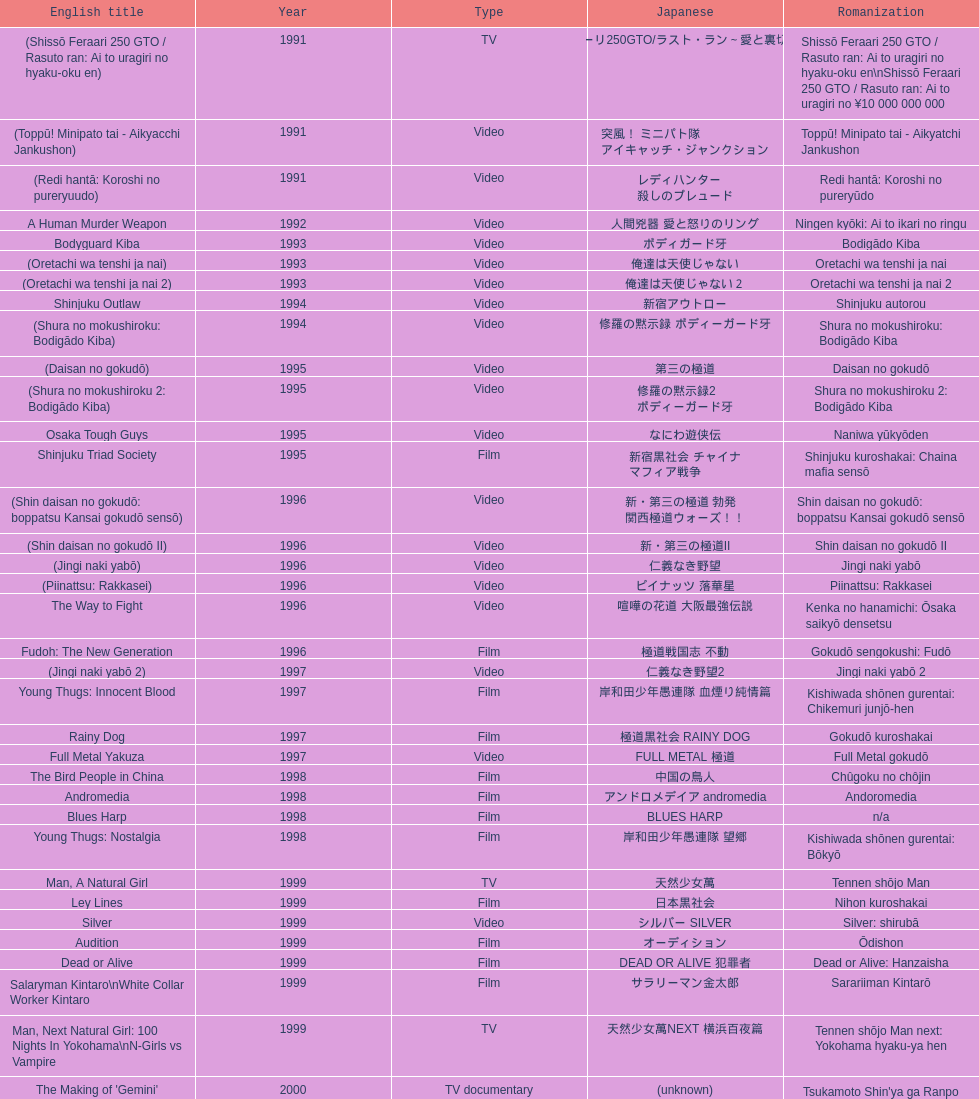Were more air on tv or video? Video. Could you parse the entire table? {'header': ['English title', 'Year', 'Type', 'Japanese', 'Romanization'], 'rows': [['(Shissō Feraari 250 GTO / Rasuto ran: Ai to uragiri no hyaku-oku en)', '1991', 'TV', '疾走フェラーリ250GTO/ラスト・ラン～愛と裏切りの百億円', 'Shissō Feraari 250 GTO / Rasuto ran: Ai to uragiri no hyaku-oku en\\nShissō Feraari 250 GTO / Rasuto ran: Ai to uragiri no ¥10 000 000 000'], ['(Toppū! Minipato tai - Aikyacchi Jankushon)', '1991', 'Video', '突風！ ミニパト隊 アイキャッチ・ジャンクション', 'Toppū! Minipato tai - Aikyatchi Jankushon'], ['(Redi hantā: Koroshi no pureryuudo)', '1991', 'Video', 'レディハンター 殺しのプレュード', 'Redi hantā: Koroshi no pureryūdo'], ['A Human Murder Weapon', '1992', 'Video', '人間兇器 愛と怒りのリング', 'Ningen kyōki: Ai to ikari no ringu'], ['Bodyguard Kiba', '1993', 'Video', 'ボディガード牙', 'Bodigādo Kiba'], ['(Oretachi wa tenshi ja nai)', '1993', 'Video', '俺達は天使じゃない', 'Oretachi wa tenshi ja nai'], ['(Oretachi wa tenshi ja nai 2)', '1993', 'Video', '俺達は天使じゃない２', 'Oretachi wa tenshi ja nai 2'], ['Shinjuku Outlaw', '1994', 'Video', '新宿アウトロー', 'Shinjuku autorou'], ['(Shura no mokushiroku: Bodigādo Kiba)', '1994', 'Video', '修羅の黙示録 ボディーガード牙', 'Shura no mokushiroku: Bodigādo Kiba'], ['(Daisan no gokudō)', '1995', 'Video', '第三の極道', 'Daisan no gokudō'], ['(Shura no mokushiroku 2: Bodigādo Kiba)', '1995', 'Video', '修羅の黙示録2 ボディーガード牙', 'Shura no mokushiroku 2: Bodigādo Kiba'], ['Osaka Tough Guys', '1995', 'Video', 'なにわ遊侠伝', 'Naniwa yūkyōden'], ['Shinjuku Triad Society', '1995', 'Film', '新宿黒社会 チャイナ マフィア戦争', 'Shinjuku kuroshakai: Chaina mafia sensō'], ['(Shin daisan no gokudō: boppatsu Kansai gokudō sensō)', '1996', 'Video', '新・第三の極道 勃発 関西極道ウォーズ！！', 'Shin daisan no gokudō: boppatsu Kansai gokudō sensō'], ['(Shin daisan no gokudō II)', '1996', 'Video', '新・第三の極道II', 'Shin daisan no gokudō II'], ['(Jingi naki yabō)', '1996', 'Video', '仁義なき野望', 'Jingi naki yabō'], ['(Piinattsu: Rakkasei)', '1996', 'Video', 'ピイナッツ 落華星', 'Piinattsu: Rakkasei'], ['The Way to Fight', '1996', 'Video', '喧嘩の花道 大阪最強伝説', 'Kenka no hanamichi: Ōsaka saikyō densetsu'], ['Fudoh: The New Generation', '1996', 'Film', '極道戦国志 不動', 'Gokudō sengokushi: Fudō'], ['(Jingi naki yabō 2)', '1997', 'Video', '仁義なき野望2', 'Jingi naki yabō 2'], ['Young Thugs: Innocent Blood', '1997', 'Film', '岸和田少年愚連隊 血煙り純情篇', 'Kishiwada shōnen gurentai: Chikemuri junjō-hen'], ['Rainy Dog', '1997', 'Film', '極道黒社会 RAINY DOG', 'Gokudō kuroshakai'], ['Full Metal Yakuza', '1997', 'Video', 'FULL METAL 極道', 'Full Metal gokudō'], ['The Bird People in China', '1998', 'Film', '中国の鳥人', 'Chûgoku no chôjin'], ['Andromedia', '1998', 'Film', 'アンドロメデイア andromedia', 'Andoromedia'], ['Blues Harp', '1998', 'Film', 'BLUES HARP', 'n/a'], ['Young Thugs: Nostalgia', '1998', 'Film', '岸和田少年愚連隊 望郷', 'Kishiwada shōnen gurentai: Bōkyō'], ['Man, A Natural Girl', '1999', 'TV', '天然少女萬', 'Tennen shōjo Man'], ['Ley Lines', '1999', 'Film', '日本黒社会', 'Nihon kuroshakai'], ['Silver', '1999', 'Video', 'シルバー SILVER', 'Silver: shirubā'], ['Audition', '1999', 'Film', 'オーディション', 'Ōdishon'], ['Dead or Alive', '1999', 'Film', 'DEAD OR ALIVE 犯罪者', 'Dead or Alive: Hanzaisha'], ['Salaryman Kintaro\\nWhite Collar Worker Kintaro', '1999', 'Film', 'サラリーマン金太郎', 'Sarariiman Kintarō'], ['Man, Next Natural Girl: 100 Nights In Yokohama\\nN-Girls vs Vampire', '1999', 'TV', '天然少女萬NEXT 横浜百夜篇', 'Tennen shōjo Man next: Yokohama hyaku-ya hen'], ["The Making of 'Gemini'", '2000', 'TV documentary', '(unknown)', "Tsukamoto Shin'ya ga Ranpo suru"], ['MPD Psycho', '2000', 'TV miniseries', '多重人格探偵サイコ', 'Tajū jinkaku tantei saiko: Amamiya Kazuhiko no kikan'], ['The City of Lost Souls\\nThe City of Strangers\\nThe Hazard City', '2000', 'Film', '漂流街 THE HAZARD CITY', 'Hyōryū-gai'], ['The Guys from Paradise', '2000', 'Film', '天国から来た男たち', 'Tengoku kara kita otoko-tachi'], ['Dead or Alive 2: Birds\\nDead or Alive 2: Runaway', '2000', 'Film', 'DEAD OR ALIVE 2 逃亡者', 'Dead or Alive 2: Tōbōsha'], ['(Kikuchi-jō monogatari: sakimori-tachi no uta)', '2001', 'Film', '鞠智城物語 防人たちの唄', 'Kikuchi-jō monogatari: sakimori-tachi no uta'], ['(Zuiketsu gensō: Tonkararin yume densetsu)', '2001', 'Film', '隧穴幻想 トンカラリン夢伝説', 'Zuiketsu gensō: Tonkararin yume densetsu'], ['Family', '2001', 'Film', 'FAMILY', 'n/a'], ['Visitor Q', '2001', 'Video', 'ビジターQ', 'Bijitā Q'], ['Ichi the Killer', '2001', 'Film', '殺し屋1', 'Koroshiya 1'], ['Agitator', '2001', 'Film', '荒ぶる魂たち', 'Araburu tamashii-tachi'], ['The Happiness of the Katakuris', '2001', 'Film', 'カタクリ家の幸福', 'Katakuri-ke no kōfuku'], ['Dead or Alive: Final', '2002', 'Film', 'DEAD OR ALIVE FINAL', 'n/a'], ['(Onna kunishū ikki)', '2002', '(unknown)', 'おんな 国衆一揆', 'Onna kunishū ikki'], ['Sabu', '2002', 'TV', 'SABU さぶ', 'Sabu'], ['Graveyard of Honor', '2002', 'Film', '新・仁義の墓場', 'Shin jingi no hakaba'], ['Shangri-La', '2002', 'Film', '金融破滅ニッポン 桃源郷の人々', "Kin'yū hametsu Nippon: Tōgenkyō no hito-bito"], ['Pandōra', '2002', 'Music video', 'パンドーラ', 'Pandōra'], ['Deadly Outlaw: Rekka\\nViolent Fire', '2002', 'Film', '実録・安藤昇侠道（アウトロー）伝 烈火', 'Jitsuroku Andō Noboru kyōdō-den: Rekka'], ['Pāto-taimu tantei', '2002', 'TV series', 'パートタイム探偵', 'Pāto-taimu tantei'], ['The Man in White', '2003', 'Film', '許されざる者', 'Yurusarezaru mono'], ['Gozu', '2003', 'Film', '極道恐怖大劇場 牛頭 GOZU', 'Gokudō kyōfu dai-gekijō: Gozu'], ['Yakuza Demon', '2003', 'Video', '鬼哭 kikoku', 'Kikoku'], ['Kōshōnin', '2003', 'TV', '交渉人', 'Kōshōnin'], ["One Missed Call\\nYou've Got a Call", '2003', 'Film', '着信アリ', 'Chakushin Ari'], ['Zebraman', '2004', 'Film', 'ゼブラーマン', 'Zeburāman'], ['Pāto-taimu tantei 2', '2004', 'TV', 'パートタイム探偵2', 'Pāto-taimu tantei 2'], ['Box segment in Three... Extremes', '2004', 'Segment in feature film', 'BOX（『美しい夜、残酷な朝』）', 'Saam gaang yi'], ['Izo', '2004', 'Film', 'IZO', 'IZO'], ['Ultraman Max', '2005', 'Episodes 15 and 16 from TV tokusatsu series', 'ウルトラマンマックス', 'Urutoraman Makkusu'], ['The Great Yokai War', '2005', 'Film', '妖怪大戦争', 'Yokai Daisenso'], ['Big Bang Love, Juvenile A\\n4.6 Billion Years of Love', '2006', 'Film', '46億年の恋', '46-okunen no koi'], ['Waru', '2006', 'Film', 'WARU', 'Waru'], ['Imprint episode from Masters of Horror', '2006', 'TV episode', 'インプリント ～ぼっけえ、きょうてえ～', 'Inpurinto ~bokke kyote~'], ['Waru: kanketsu-hen', '2006', 'Video', '', 'Waru: kanketsu-hen'], ['Sun Scarred', '2006', 'Film', '太陽の傷', 'Taiyo no kizu'], ['Sukiyaki Western Django', '2007', 'Film', 'スキヤキ・ウエスタン ジャンゴ', 'Sukiyaki wesutān jango'], ['Crows Zero', '2007', 'Film', 'クローズZERO', 'Kurōzu Zero'], ['Like a Dragon', '2007', 'Film', '龍が如く 劇場版', 'Ryu ga Gotoku Gekijōban'], ['Zatoichi', '2007', 'Stageplay', '座頭市', 'Zatōichi'], ['Detective Story', '2007', 'Film', '探偵物語', 'Tantei monogatari'], ["God's Puzzle", '2008', 'Film', '神様のパズル', 'Kamisama no pazuru'], ['K-tai Investigator 7', '2008', 'TV', 'ケータイ捜査官7', 'Keitai Sōsakan 7'], ['Yatterman', '2009', 'Film', 'ヤッターマン', 'Yattaaman'], ['Crows Zero 2', '2009', 'Film', 'クローズZERO 2', 'Kurōzu Zero 2'], ['Thirteen Assassins', '2010', 'Film', '十三人の刺客', 'Jûsan-nin no shikaku'], ['Zebraman 2: Attack on Zebra City', '2010', 'Film', 'ゼブラーマン -ゼブラシティの逆襲', 'Zeburāman -Zebura Shiti no Gyakushū'], ['Ninja Kids!!!', '2011', 'Film', '忍たま乱太郎', 'Nintama Rantarō'], ['Hara-Kiri: Death of a Samurai', '2011', 'Film', '一命', 'Ichimei'], ['Ace Attorney', '2012', 'Film', '逆転裁判', 'Gyakuten Saiban'], ["For Love's Sake", '2012', 'Film', '愛と誠', 'Ai to makoto'], ['Lesson of the Evil', '2012', 'Film', '悪の教典', 'Aku no Kyōten'], ['Shield of Straw', '2013', 'Film', '藁の楯', 'Wara no Tate'], ['The Mole Song: Undercover Agent Reiji', '2013', 'Film', '土竜の唄\u3000潜入捜査官 REIJI', 'Mogura no uta – sennyu sosakan: Reiji']]} 